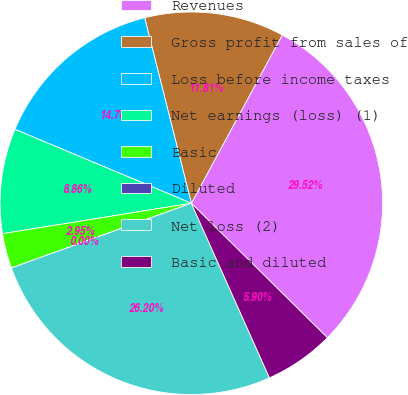Convert chart to OTSL. <chart><loc_0><loc_0><loc_500><loc_500><pie_chart><fcel>Revenues<fcel>Gross profit from sales of<fcel>Loss before income taxes<fcel>Net earnings (loss) (1)<fcel>Basic<fcel>Diluted<fcel>Net loss (2)<fcel>Basic and diluted<nl><fcel>29.52%<fcel>11.81%<fcel>14.76%<fcel>8.86%<fcel>2.95%<fcel>0.0%<fcel>26.2%<fcel>5.9%<nl></chart> 